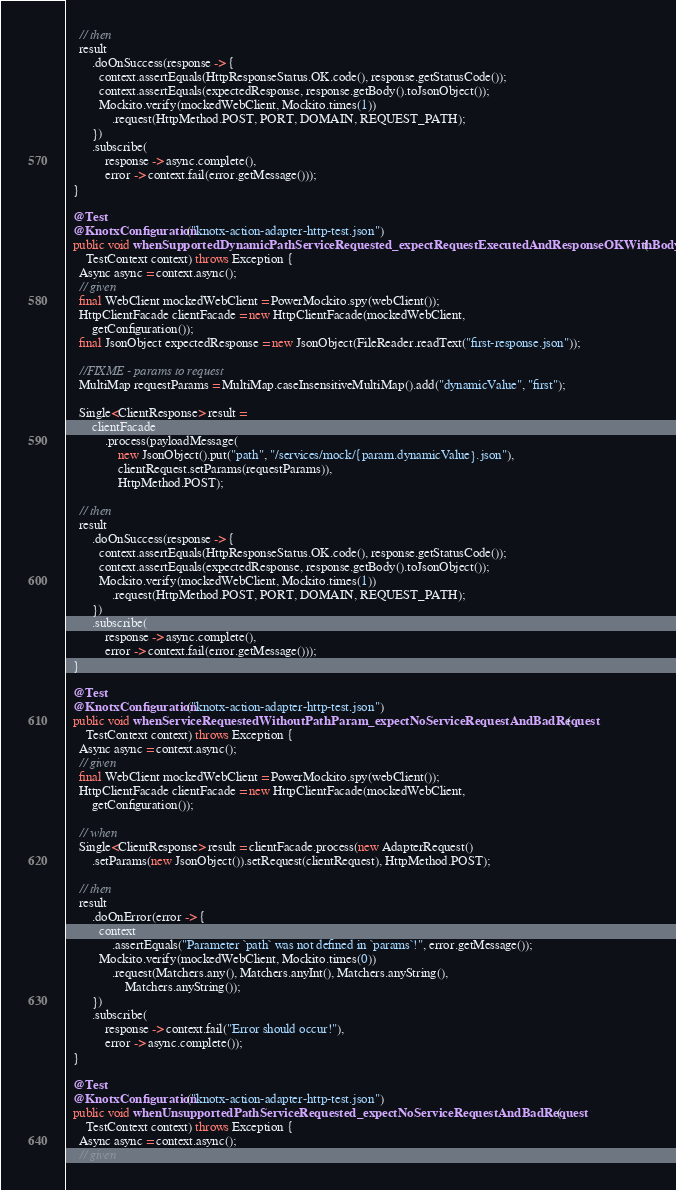<code> <loc_0><loc_0><loc_500><loc_500><_Java_>
    // then
    result
        .doOnSuccess(response -> {
          context.assertEquals(HttpResponseStatus.OK.code(), response.getStatusCode());
          context.assertEquals(expectedResponse, response.getBody().toJsonObject());
          Mockito.verify(mockedWebClient, Mockito.times(1))
              .request(HttpMethod.POST, PORT, DOMAIN, REQUEST_PATH);
        })
        .subscribe(
            response -> async.complete(),
            error -> context.fail(error.getMessage()));
  }

  @Test
  @KnotxConfiguration("knotx-action-adapter-http-test.json")
  public void whenSupportedDynamicPathServiceRequested_expectRequestExecutedAndResponseOKWithBody(
      TestContext context) throws Exception {
    Async async = context.async();
    // given
    final WebClient mockedWebClient = PowerMockito.spy(webClient());
    HttpClientFacade clientFacade = new HttpClientFacade(mockedWebClient,
        getConfiguration());
    final JsonObject expectedResponse = new JsonObject(FileReader.readText("first-response.json"));

    //FIXME - params to request
    MultiMap requestParams = MultiMap.caseInsensitiveMultiMap().add("dynamicValue", "first");

    Single<ClientResponse> result =
        clientFacade
            .process(payloadMessage(
                new JsonObject().put("path", "/services/mock/{param.dynamicValue}.json"),
                clientRequest.setParams(requestParams)),
                HttpMethod.POST);

    // then
    result
        .doOnSuccess(response -> {
          context.assertEquals(HttpResponseStatus.OK.code(), response.getStatusCode());
          context.assertEquals(expectedResponse, response.getBody().toJsonObject());
          Mockito.verify(mockedWebClient, Mockito.times(1))
              .request(HttpMethod.POST, PORT, DOMAIN, REQUEST_PATH);
        })
        .subscribe(
            response -> async.complete(),
            error -> context.fail(error.getMessage()));
  }

  @Test
  @KnotxConfiguration("knotx-action-adapter-http-test.json")
  public void whenServiceRequestedWithoutPathParam_expectNoServiceRequestAndBadRequest(
      TestContext context) throws Exception {
    Async async = context.async();
    // given
    final WebClient mockedWebClient = PowerMockito.spy(webClient());
    HttpClientFacade clientFacade = new HttpClientFacade(mockedWebClient,
        getConfiguration());

    // when
    Single<ClientResponse> result = clientFacade.process(new AdapterRequest()
        .setParams(new JsonObject()).setRequest(clientRequest), HttpMethod.POST);

    // then
    result
        .doOnError(error -> {
          context
              .assertEquals("Parameter `path` was not defined in `params`!", error.getMessage());
          Mockito.verify(mockedWebClient, Mockito.times(0))
              .request(Matchers.any(), Matchers.anyInt(), Matchers.anyString(),
                  Matchers.anyString());
        })
        .subscribe(
            response -> context.fail("Error should occur!"),
            error -> async.complete());
  }

  @Test
  @KnotxConfiguration("knotx-action-adapter-http-test.json")
  public void whenUnsupportedPathServiceRequested_expectNoServiceRequestAndBadRequest(
      TestContext context) throws Exception {
    Async async = context.async();
    // given</code> 